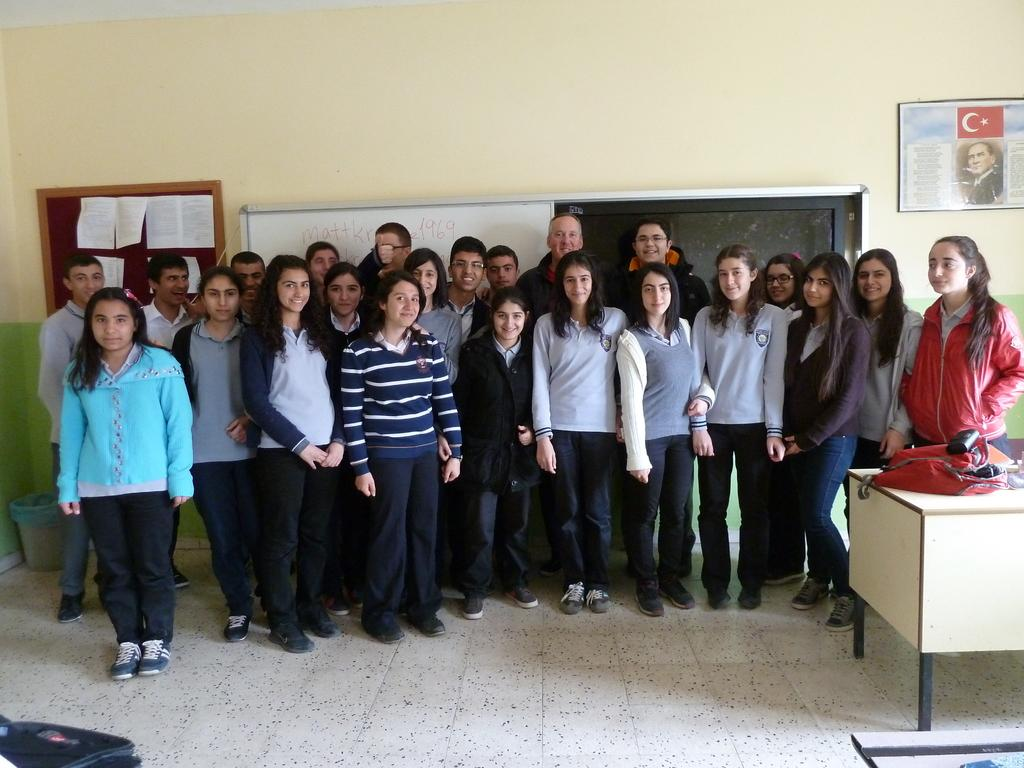What are the people in the image doing? There is a group of people standing in the image. What object can be seen on the table? There is a bag on the table in the image. What part of the room can be seen in the image? The floor is visible in the image. What type of decoration or feature is on the wall in the background? There are boards on the wall in the background. How many beds are visible in the image? There are no beds visible in the image. What type of thing is being sold in the shop in the image? There is no shop present in the image. 